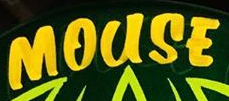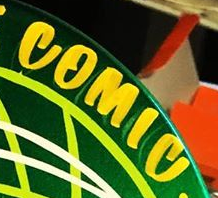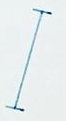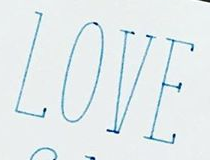Identify the words shown in these images in order, separated by a semicolon. MOUSE; COMIC; I; LOVE 